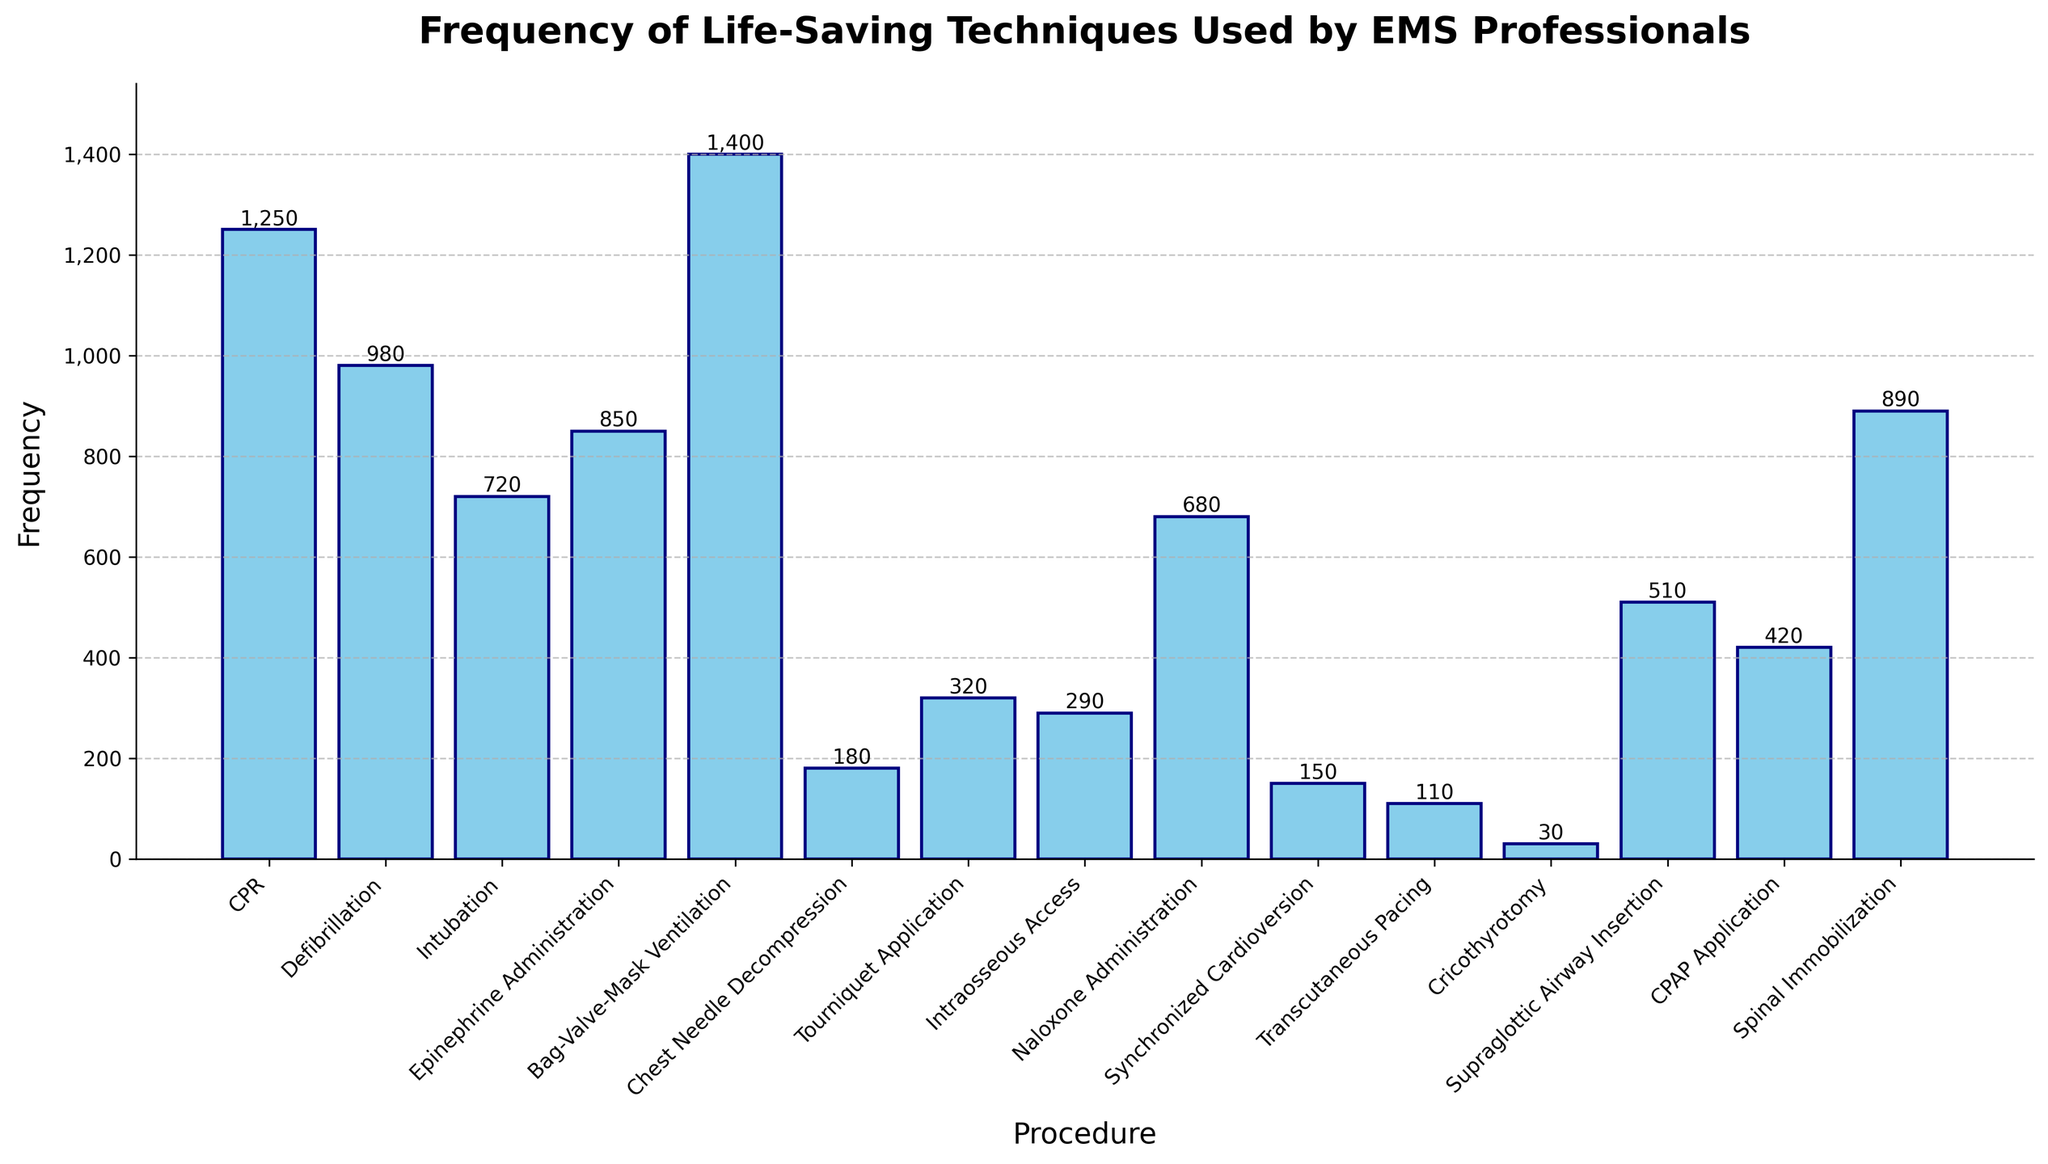Which procedure is used the most frequently? The tallest bar in the chart represents the procedure with the highest frequency. By observing the chart, the tallest bar corresponds to "Bag-Valve-Mask Ventilation".
Answer: Bag-Valve-Mask Ventilation Which procedure is used the least frequently? The shortest bar in the chart represents the procedure with the lowest frequency. By observing the chart, the shortest bar corresponds to "Cricothyrotomy".
Answer: Cricothyrotomy How many times is CPR used compared to Naloxone Administration? To find this, locate the bars for "CPR" and "Naloxone Administration" and compare their heights. The frequency for CPR is 1250 and for Naloxone Administration is 680. By division: 1250 / 680 ≈ 1.84.
Answer: About 1.84 times What is the combined frequency of Epinephrine Administration and Spinal Immobilization? Locate the bars for "Epinephrine Administration" and "Spinal Immobilization" and add their heights. The frequencies are 850 and 890 respectively. The combined frequency is 850 + 890 = 1740.
Answer: 1740 Which procedures have a frequency less than 500? Identify bars that do not reach the 500 mark on the frequency axis. These procedures are: "Chest Needle Decompression," "Tourniquet Application," "Intraosseous Access," "Synchronized Cardioversion," "Transcutaneous Pacing," and "Cricothyrotomy."
Answer: Chest Needle Decompression, Tourniquet Application, Intraosseous Access, Synchronized Cardioversion, Transcutaneous Pacing, Cricothyrotomy Are there more procedures with frequencies above or below 750? Count the number of bars above and below the 750 mark. Above 750: 6 procedures (CPR, Defibrillation, Intubation, Epinephrine Administration, Bag-Valve-Mask Ventilation, Spinal Immobilization). Below 750: 9 procedures. Therefore, more procedures have frequencies below 750.
Answer: Below 750 What is the frequency difference between Defibrillation and Intubation? Locate bars for "Defibrillation" and "Intubation" and subtract the smaller value from the larger one. The frequency for Defibrillation is 980 and for Intubation is 720. The difference is 980 - 720 = 260.
Answer: 260 Which has a higher frequency, CPAP Application or Supraglottic Airway Insertion? Compare the heights of the bars for "CPAP Application" and "Supraglottic Airway Insertion". The frequency for CPAP Application is 420, whereas for Supraglottic Airway Insertion, it is 510. Hence, Supraglottic Airway Insertion is higher.
Answer: Supraglottic Airway Insertion Is the frequency of Chest Needle Decompression higher or lower than Tourniquet Application plus Intraosseous Access? The frequencies are: Chest Needle Decompression = 180, Tourniquet Application = 320, Intraosseous Access = 290. The sum of Tourniquet Application and Intraosseous Access = 320 + 290 = 610. Since 180 < 610, Chest Needle Decompression is lower.
Answer: Lower What is the total frequency of all listed procedures? Add all of the frequencies together: 1250 + 980 + 720 + 850 + 1400 + 180 + 320 + 290 + 680 + 150 + 110 + 30 + 510 + 420 + 890 = 9780.
Answer: 9780 